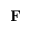Convert formula to latex. <formula><loc_0><loc_0><loc_500><loc_500>F</formula> 